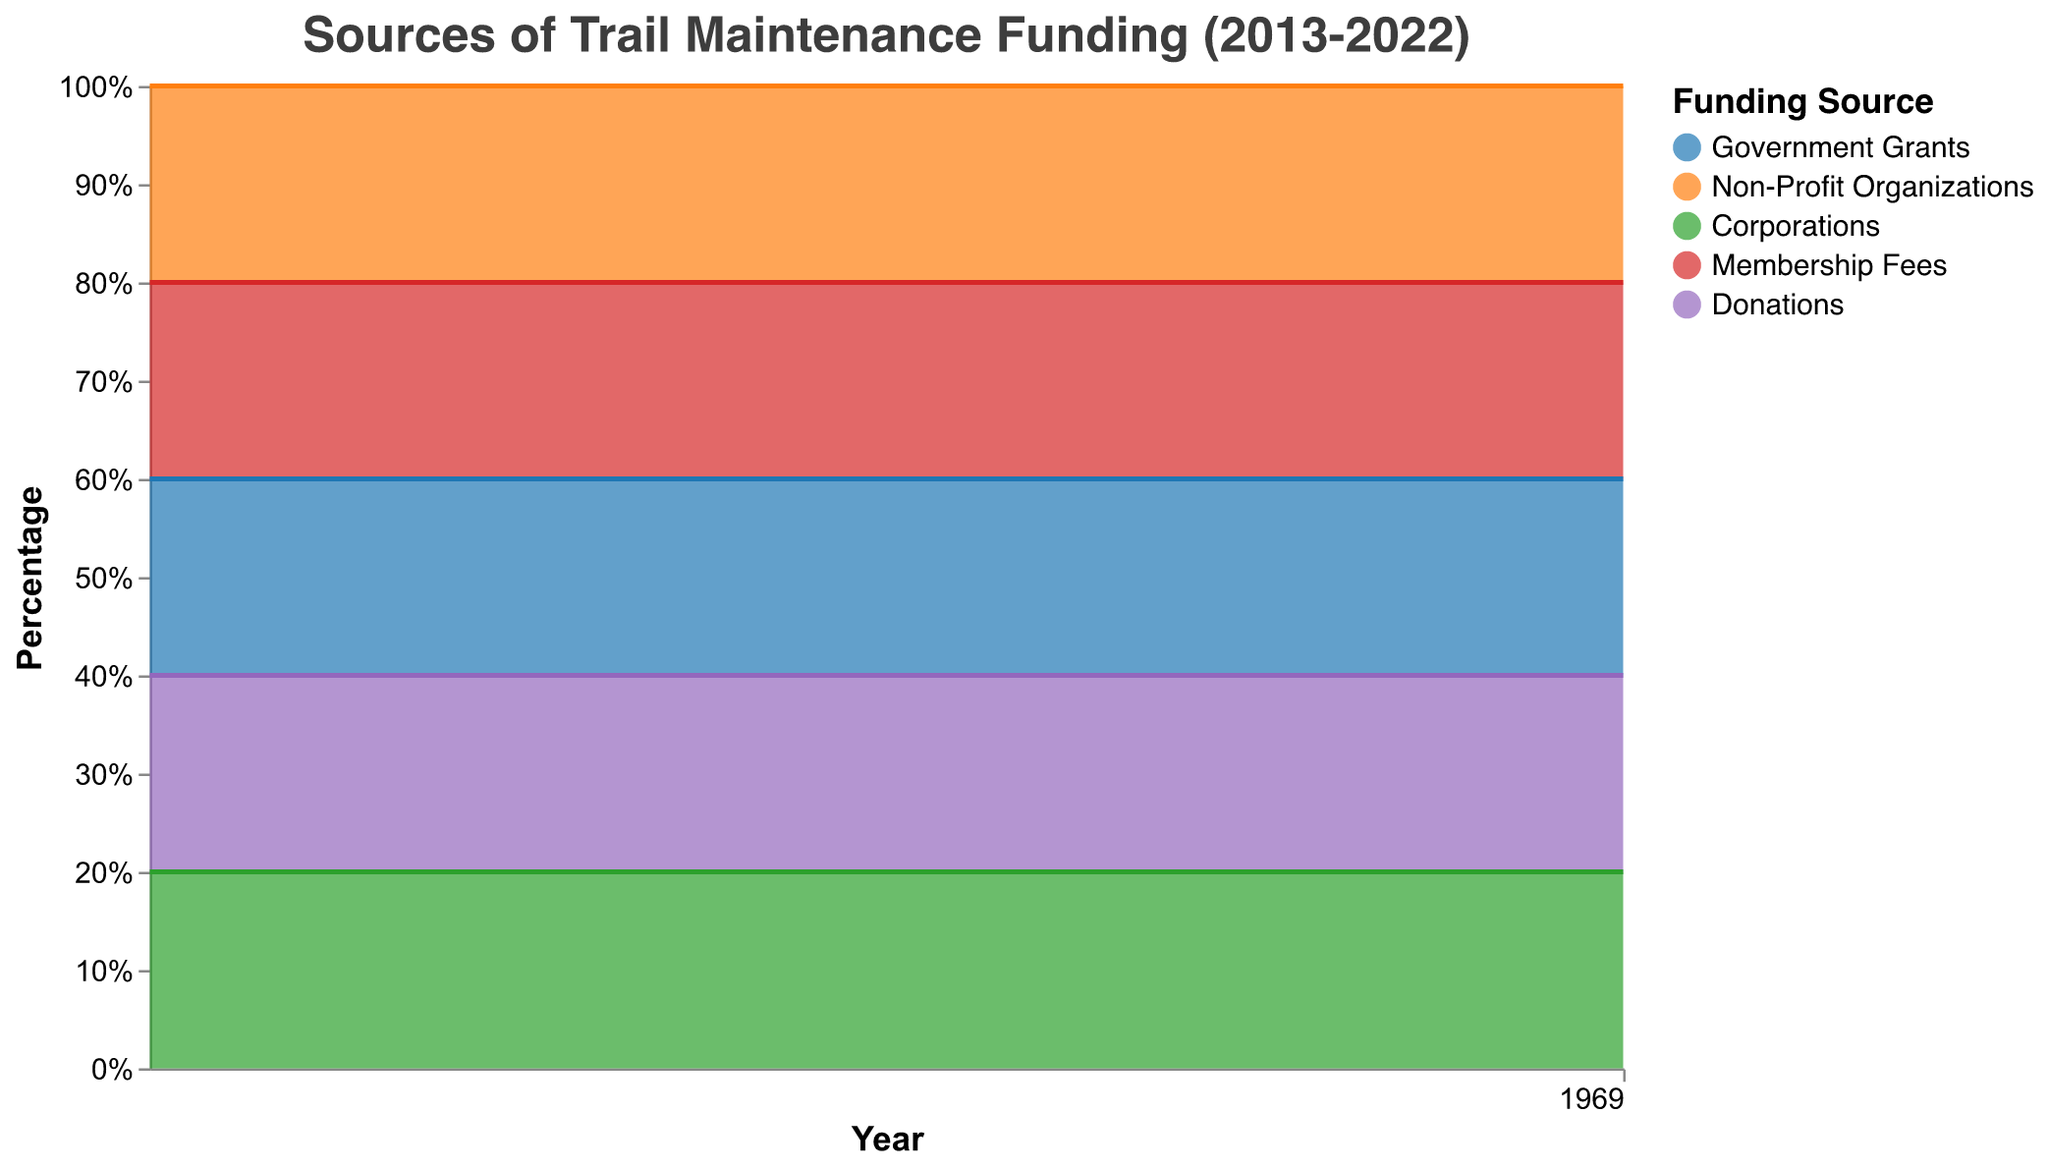What is the primary funding source for trail maintenance in 2013? In the 100% Stacked Area Chart, for the year 2013, the largest section belongs to "Government Grants" which occupies the topmost part of the figure.
Answer: Government Grants How does the contribution of Government Grants change from 2013 to 2022? The chart displays a continuous decrease in the contribution of Government Grants over the years. It starts at 40% in 2013 and drops to 10% by 2022.
Answer: It decreases Which funding source shows the most significant increase in its percentage allocation over the decade? Observing the chart, "Non-Profit Organizations" show the most significant increase, starting from 25% in 2013 and reaching up to 40% in 2020, and then maintaining 35% in the last two years.
Answer: Non-Profit Organizations What are the percentages of Membership Fees and Donations combined in 2022? Both Membership Fees and Donations maintain a consistent percentage of 10% each throughout the years. Together in 2022, they sum to 20%.
Answer: 20% Which funding source had no change in its percentage allocation throughout the years? Both "Membership Fees" and "Donations" consistently maintain a percentage of 10% for every year from 2013 to 2022.
Answer: Membership Fees and Donations Which year did Corporations start contributing more to trail maintenance than Government Grants? Corporations' contribution becomes more significant than Government Grants starting 2016. This is evident as Government Grants drop to 25% while Corporations rise to 20% in 2016.
Answer: 2016 How does the visual representation of Non-Profit Organizations compare to Corporations in 2015? In 2015, the chart shows Non-Profit Organizations at 35%, overtaking Corporations which remain at 15%. This difference is visualized by the larger area occupied by Non-Profit Organizations.
Answer: Non-Profit Organizations have a larger area What is the trend for the contribution of Corporations from 2013 to 2022? The percentage for Corporations starts at 15% in 2013, steadily increases over the years, and stabilizes at 35% from 2021 onwards.
Answer: It increases Which year has the highest combined contribution from Government Grants and Non-Profit Organizations? By inspecting the areas in the chart, 2014 shows the highest combined contribution from Government Grants (35%) and Non-Profit Organizations (30%), totaling 65%.
Answer: 2014 